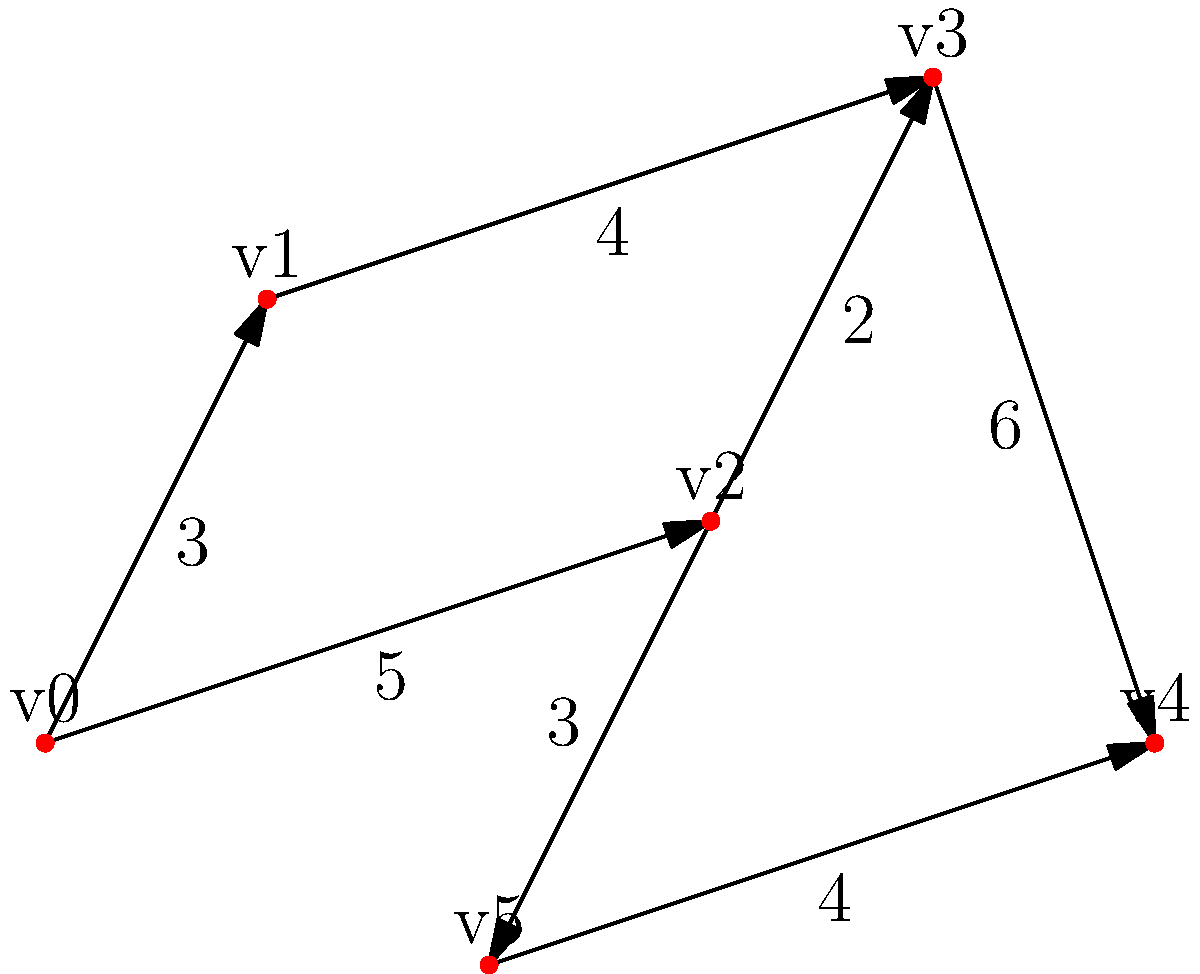In your latest diorama project, you need to wire LED lights through a complex structure. The graph represents possible wiring paths, where vertices are connection points and edge weights are the lengths of wire needed (in cm). What is the shortest path from v0 to v4, and what is its total length? To find the shortest path from v0 to v4, we'll use Dijkstra's algorithm:

1. Initialize:
   - Distance to v0 = 0
   - Distance to all other vertices = infinity
   - Previous vertex for all = undefined
   - Unvisited set = {v0, v1, v2, v3, v4, v5}

2. Starting from v0:
   - Update neighbors: v1 (3), v2 (5)
   - Mark v0 as visited

3. Select v1 (shortest distance):
   - Update neighbors: v3 (3 + 4 = 7)
   - Mark v1 as visited

4. Select v2 (next shortest):
   - Update neighbors: v3 (5 + 2 = 7), v5 (5 + 3 = 8)
   - Mark v2 as visited

5. Select v3 (next shortest):
   - Update neighbors: v4 (7 + 6 = 13)
   - Mark v3 as visited

6. Select v5 (next shortest):
   - Update neighbors: v4 (8 + 4 = 12)
   - Mark v5 as visited

7. Select v4 (final destination):
   - Mark v4 as visited

The shortest path is v0 → v2 → v5 → v4 with a total length of 12 cm.
Answer: v0 → v2 → v5 → v4; 12 cm 